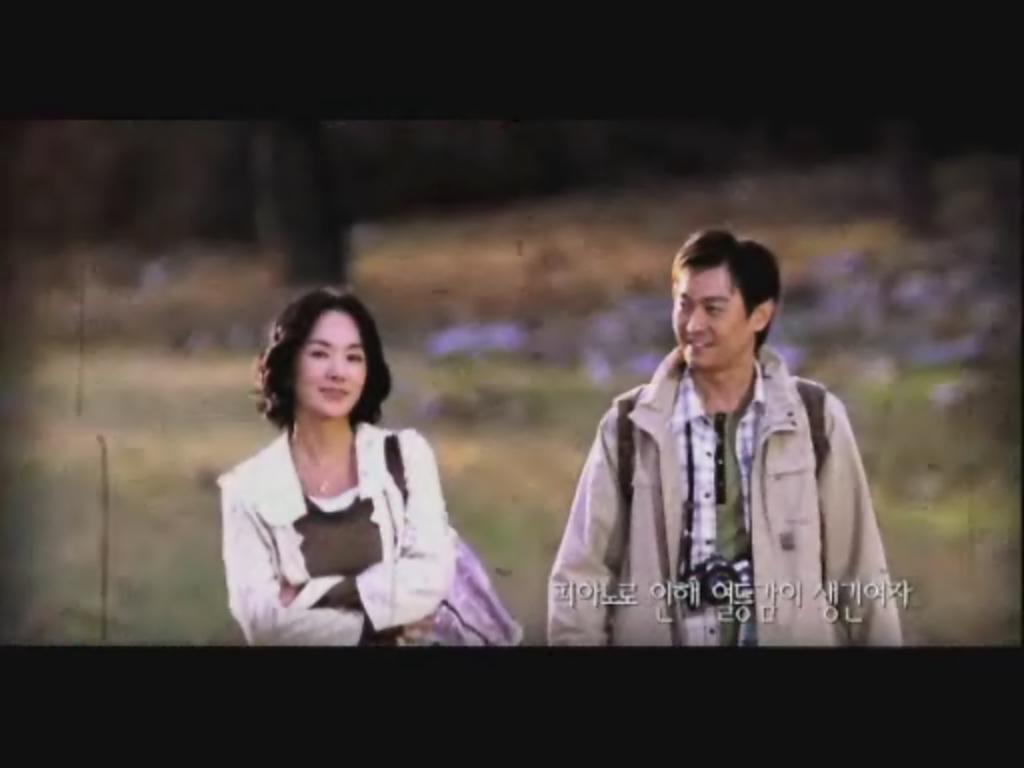How many persons are in the image? There is one person in the image. What is the person holding in the image? The person is holding a basketball. What can be seen near the person in the image? The person is standing near a hoop. What type of honey can be seen dripping from the basketball in the image? There is no honey present in the image, and the basketball is not dripping anything. 